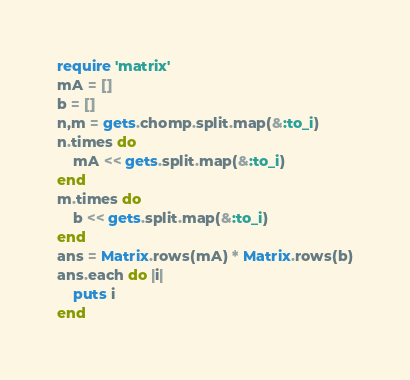<code> <loc_0><loc_0><loc_500><loc_500><_Ruby_>require 'matrix'
mA = []
b = []
n,m = gets.chomp.split.map(&:to_i)
n.times do
    mA << gets.split.map(&:to_i)
end
m.times do
    b << gets.split.map(&:to_i)
end
ans = Matrix.rows(mA) * Matrix.rows(b)
ans.each do |i|
    puts i
end</code> 